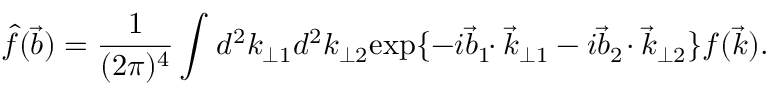<formula> <loc_0><loc_0><loc_500><loc_500>\hat { f } ( \vec { b } ) = \frac { 1 } { ( 2 \pi ) ^ { 4 } } \int ^ { 2 } k _ { \perp 1 } ^ { 2 } k _ { \perp 2 } e x p \{ - i \vec { b } _ { 1 } \, \cdot \vec { k } _ { \perp 1 } - i \vec { b } _ { 2 } \, \cdot \vec { k } _ { \perp 2 } \} f ( \vec { k } ) .</formula> 